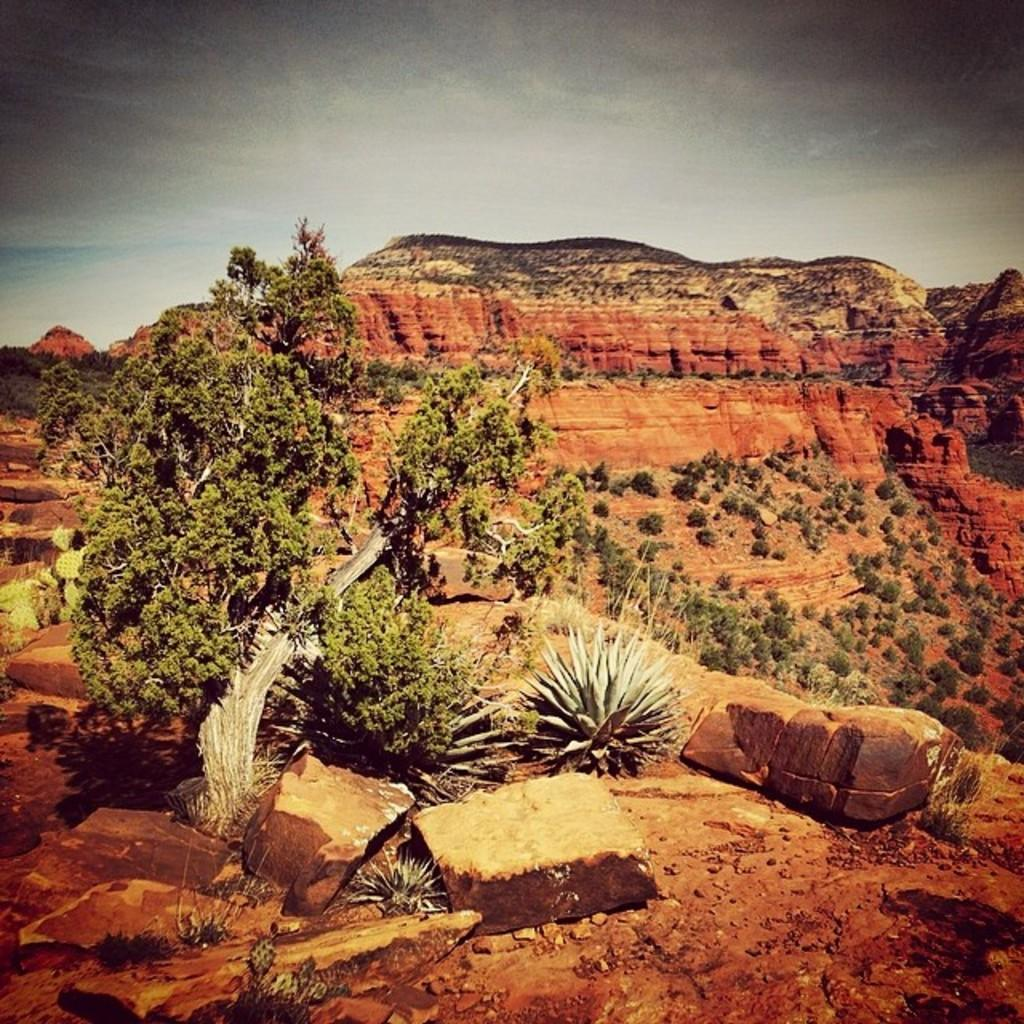What type of natural elements can be seen in the image? There are rocks, plants, and trees visible in the image. What type of landscape is depicted in the background of the image? There are mountains in the background of the image. What is the condition of the sky in the image? The sky is clear in the image. What type of dirt is being used to fill the vessel in the image? There is no vessel or dirt present in the image. Can you describe the mountain's texture in the image? There is no specific texture mentioned for the mountains in the image, but they appear to be rocky and rugged. 